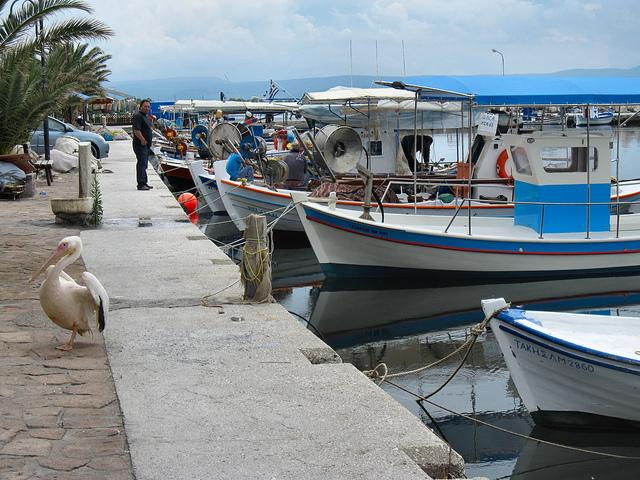What is the name of the large bird?

Choices:
A) flamingo
B) seahawk
C) stork
D) pelican stork 